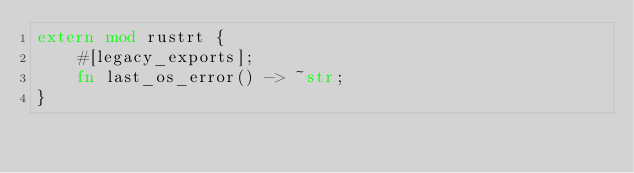<code> <loc_0><loc_0><loc_500><loc_500><_Rust_>extern mod rustrt {
    #[legacy_exports];
    fn last_os_error() -> ~str;
}</code> 